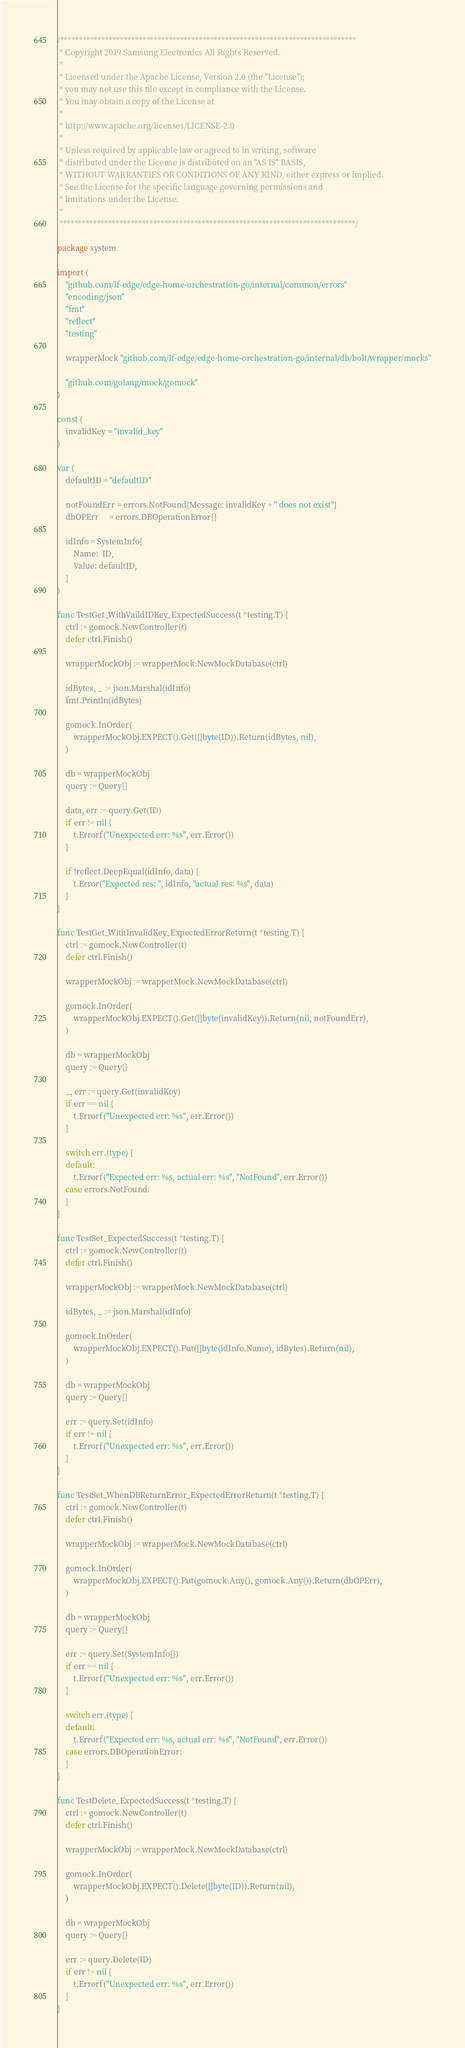<code> <loc_0><loc_0><loc_500><loc_500><_Go_>/*******************************************************************************
 * Copyright 2019 Samsung Electronics All Rights Reserved.
 *
 * Licensed under the Apache License, Version 2.0 (the "License");
 * you may not use this file except in compliance with the License.
 * You may obtain a copy of the License at
 *
 * http://www.apache.org/licenses/LICENSE-2.0
 *
 * Unless required by applicable law or agreed to in writing, software
 * distributed under the License is distributed on an "AS IS" BASIS,
 * WITHOUT WARRANTIES OR CONDITIONS OF ANY KIND, either express or implied.
 * See the License for the specific language governing permissions and
 * limitations under the License.
 *
 *******************************************************************************/

package system

import (
	"github.com/lf-edge/edge-home-orchestration-go/internal/common/errors"
	"encoding/json"
	"fmt"
	"reflect"
	"testing"

	wrapperMock "github.com/lf-edge/edge-home-orchestration-go/internal/db/bolt/wrapper/mocks"

	"github.com/golang/mock/gomock"
)

const (
	invalidKey = "invalid_key"
)

var (
	defaultID = "defaultID"

	notFoundErr = errors.NotFound{Message: invalidKey + " does not exist"}
	dbOPErr     = errors.DBOperationError{}

	idInfo = SystemInfo{
		Name:  ID,
		Value: defaultID,
	}
)

func TestGet_WithVaildIDKey_ExpectedSuccess(t *testing.T) {
	ctrl := gomock.NewController(t)
	defer ctrl.Finish()

	wrapperMockObj := wrapperMock.NewMockDatabase(ctrl)

	idBytes, _ := json.Marshal(idInfo)
	fmt.Println(idBytes)

	gomock.InOrder(
		wrapperMockObj.EXPECT().Get([]byte(ID)).Return(idBytes, nil),
	)

	db = wrapperMockObj
	query := Query{}

	data, err := query.Get(ID)
	if err != nil {
		t.Errorf("Unexpected err: %s", err.Error())
	}

	if !reflect.DeepEqual(idInfo, data) {
		t.Error("Expected res: ", idInfo, "actual res: %s", data)
	}
}

func TestGet_WithInvalidKey_ExpectedErrorReturn(t *testing.T) {
	ctrl := gomock.NewController(t)
	defer ctrl.Finish()

	wrapperMockObj := wrapperMock.NewMockDatabase(ctrl)

	gomock.InOrder(
		wrapperMockObj.EXPECT().Get([]byte(invalidKey)).Return(nil, notFoundErr),
	)

	db = wrapperMockObj
	query := Query{}

	_, err := query.Get(invalidKey)
	if err == nil {
		t.Errorf("Unexpected err: %s", err.Error())
	}

	switch err.(type) {
	default:
		t.Errorf("Expected err: %s, actual err: %s", "NotFound", err.Error())
	case errors.NotFound:
	}
}

func TestSet_ExpectedSuccess(t *testing.T) {
	ctrl := gomock.NewController(t)
	defer ctrl.Finish()

	wrapperMockObj := wrapperMock.NewMockDatabase(ctrl)

	idBytes, _ := json.Marshal(idInfo)

	gomock.InOrder(
		wrapperMockObj.EXPECT().Put([]byte(idInfo.Name), idBytes).Return(nil),
	)

	db = wrapperMockObj
	query := Query{}

	err := query.Set(idInfo)
	if err != nil {
		t.Errorf("Unexpected err: %s", err.Error())
	}
}

func TestSet_WhenDBReturnError_ExpectedErrorReturn(t *testing.T) {
	ctrl := gomock.NewController(t)
	defer ctrl.Finish()

	wrapperMockObj := wrapperMock.NewMockDatabase(ctrl)

	gomock.InOrder(
		wrapperMockObj.EXPECT().Put(gomock.Any(), gomock.Any()).Return(dbOPErr),
	)

	db = wrapperMockObj
	query := Query{}

	err := query.Set(SystemInfo{})
	if err == nil {
		t.Errorf("Unexpected err: %s", err.Error())
	}

	switch err.(type) {
	default:
		t.Errorf("Expected err: %s, actual err: %s", "NotFound", err.Error())
	case errors.DBOperationError:
	}
}

func TestDelete_ExpectedSuccess(t *testing.T) {
	ctrl := gomock.NewController(t)
	defer ctrl.Finish()

	wrapperMockObj := wrapperMock.NewMockDatabase(ctrl)

	gomock.InOrder(
		wrapperMockObj.EXPECT().Delete([]byte(ID)).Return(nil),
	)

	db = wrapperMockObj
	query := Query{}

	err := query.Delete(ID)
	if err != nil {
		t.Errorf("Unexpected err: %s", err.Error())
	}
}
</code> 